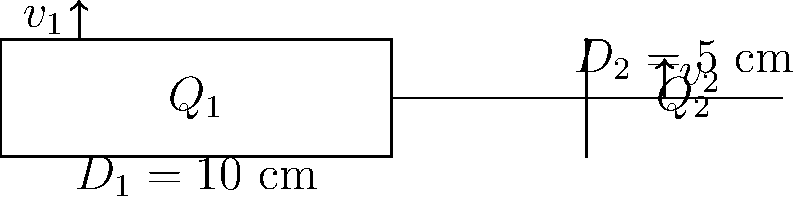While walking by a construction site, you notice water flowing through a pipe system. The first section has a diameter of 10 cm, which then narrows to 5 cm. If the water velocity in the larger pipe is 2 m/s, what is the velocity in the smaller pipe? To solve this problem, we can use the principle of continuity in fluid dynamics. The steps are as follows:

1) The continuity equation states that the volume flow rate is constant throughout the pipe system:

   $$Q_1 = Q_2$$

2) The volume flow rate is the product of the cross-sectional area and the velocity:

   $$A_1v_1 = A_2v_2$$

3) The cross-sectional area of a circular pipe is $A = \pi r^2 = \pi (D/2)^2$:

   $$\pi (D_1/2)^2 v_1 = \pi (D_2/2)^2 v_2$$

4) Substitute the given values:

   $$\pi (10/2)^2 \cdot 2 = \pi (5/2)^2 v_2$$

5) The $\pi$ cancels out:

   $$25 \cdot 2 = 6.25 v_2$$

6) Solve for $v_2$:

   $$v_2 = \frac{50}{6.25} = 8 \text{ m/s}$$

Therefore, the velocity in the smaller pipe is 8 m/s.
Answer: 8 m/s 